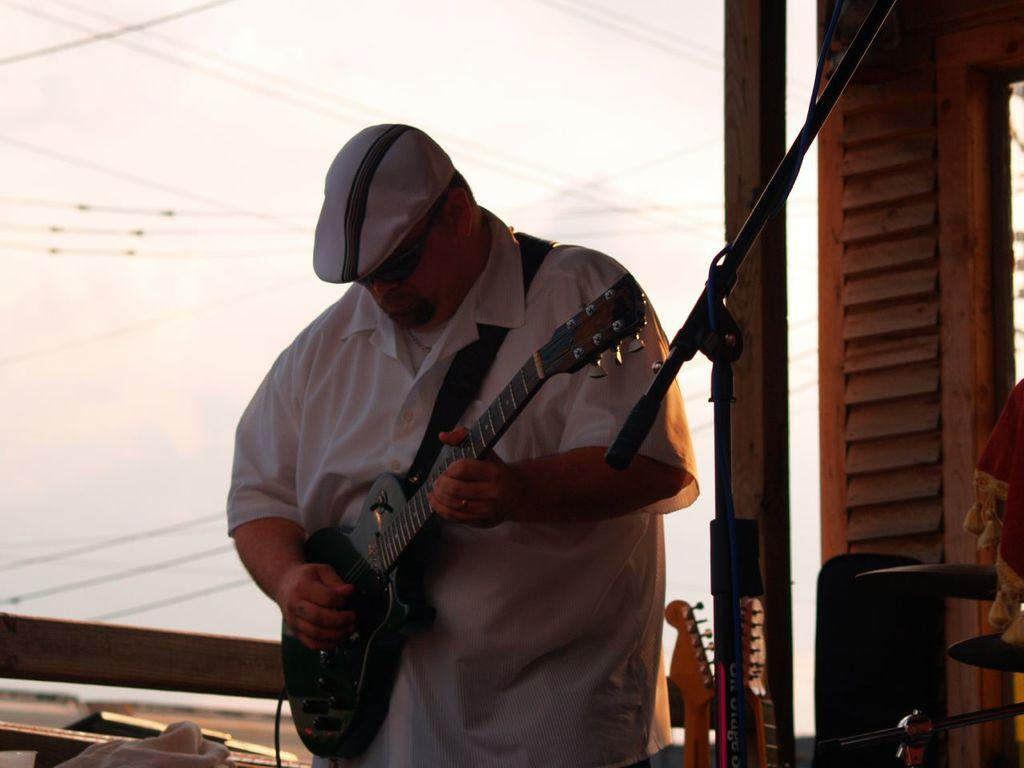What is the person in the image doing? The person is standing and playing a musical instrument. What instrument is the person playing? The person is holding a guitar and playing it. What can be seen on the person's head? The person is wearing a cap. What color is the banner in the background? There is a white color banner in the background. What else can be seen in the background related to music? There is at least one other musical instrument visible in the background. How many planes are flying in the background of the image? There are no planes visible in the background of the image. What type of support does the person need to play the guitar? The person does not require any specific support to play the guitar, as they are standing and holding it. 